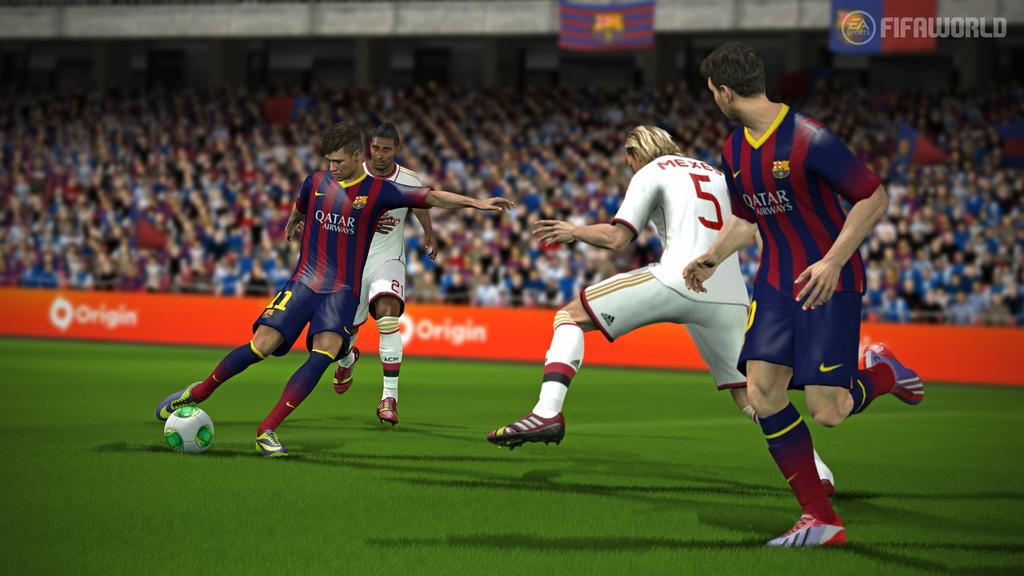What is the main subject of the image? The image depicts a video game. What is the person in the image doing? The person is running and kicking a ball. How many other persons are running in the same area? There are three other persons running in the same area. What can be seen in the background of the image? There is a group of people in the background. What type of riddle is the manager solving in the image? There is no manager or riddle present in the image; it depicts a video game with people running and kicking a ball. What type of crops is the farmer growing in the image? There is no farmer or crops present in the image; it depicts a video game with people running and kicking a ball. 